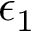Convert formula to latex. <formula><loc_0><loc_0><loc_500><loc_500>\epsilon _ { 1 }</formula> 